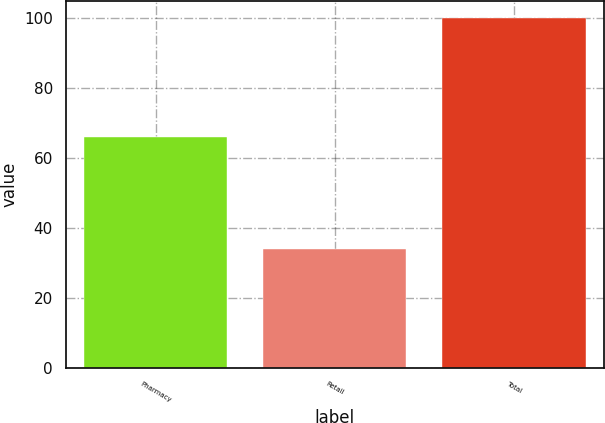Convert chart. <chart><loc_0><loc_0><loc_500><loc_500><bar_chart><fcel>Pharmacy<fcel>Retail<fcel>Total<nl><fcel>66<fcel>34<fcel>100<nl></chart> 